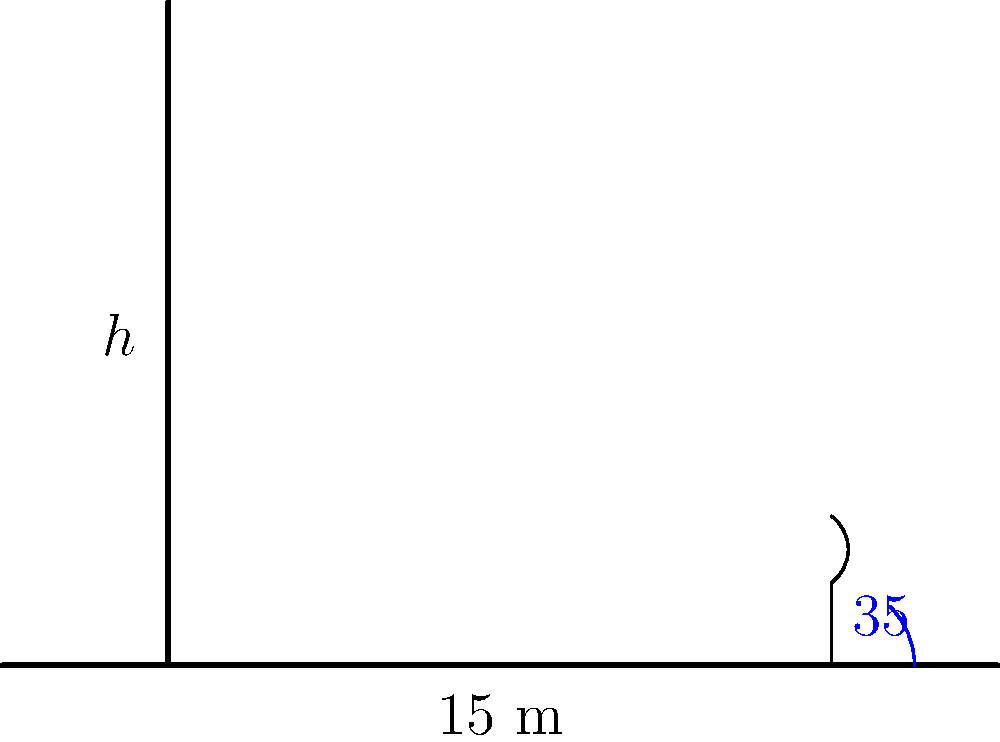Leah's friend wants to measure the height of the town hall using a simple clinometer. He stands 15 meters away from the building and measures the angle to the top of the building to be 35°. How tall is the building? Let's approach this step-by-step:

1) In this problem, we have a right triangle. The building forms the vertical side (opposite to the angle), the distance from the observer to the building forms the horizontal side (adjacent to the angle), and the line of sight forms the hypotenuse.

2) We know:
   - The adjacent side (distance to the building) is 15 meters
   - The angle of elevation is 35°
   - We need to find the opposite side (height of the building)

3) In this case, we should use the tangent ratio. The tangent of an angle in a right triangle is the ratio of the opposite side to the adjacent side.

4) The formula is:
   $\tan(\theta) = \frac{\text{opposite}}{\text{adjacent}}$

5) Let's plug in what we know:
   $\tan(35°) = \frac{h}{15}$

6) To solve for $h$, we multiply both sides by 15:
   $15 \cdot \tan(35°) = h$

7) Now we can calculate:
   $h = 15 \cdot \tan(35°) \approx 15 \cdot 0.7002 \approx 10.503$ meters

8) Rounding to the nearest meter, the height is approximately 11 meters.
Answer: 11 meters 